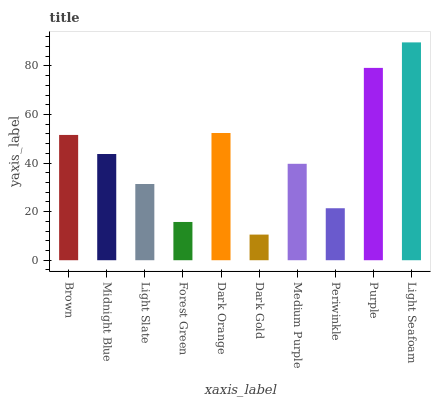Is Dark Gold the minimum?
Answer yes or no. Yes. Is Light Seafoam the maximum?
Answer yes or no. Yes. Is Midnight Blue the minimum?
Answer yes or no. No. Is Midnight Blue the maximum?
Answer yes or no. No. Is Brown greater than Midnight Blue?
Answer yes or no. Yes. Is Midnight Blue less than Brown?
Answer yes or no. Yes. Is Midnight Blue greater than Brown?
Answer yes or no. No. Is Brown less than Midnight Blue?
Answer yes or no. No. Is Midnight Blue the high median?
Answer yes or no. Yes. Is Medium Purple the low median?
Answer yes or no. Yes. Is Periwinkle the high median?
Answer yes or no. No. Is Midnight Blue the low median?
Answer yes or no. No. 